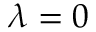<formula> <loc_0><loc_0><loc_500><loc_500>\lambda = 0</formula> 